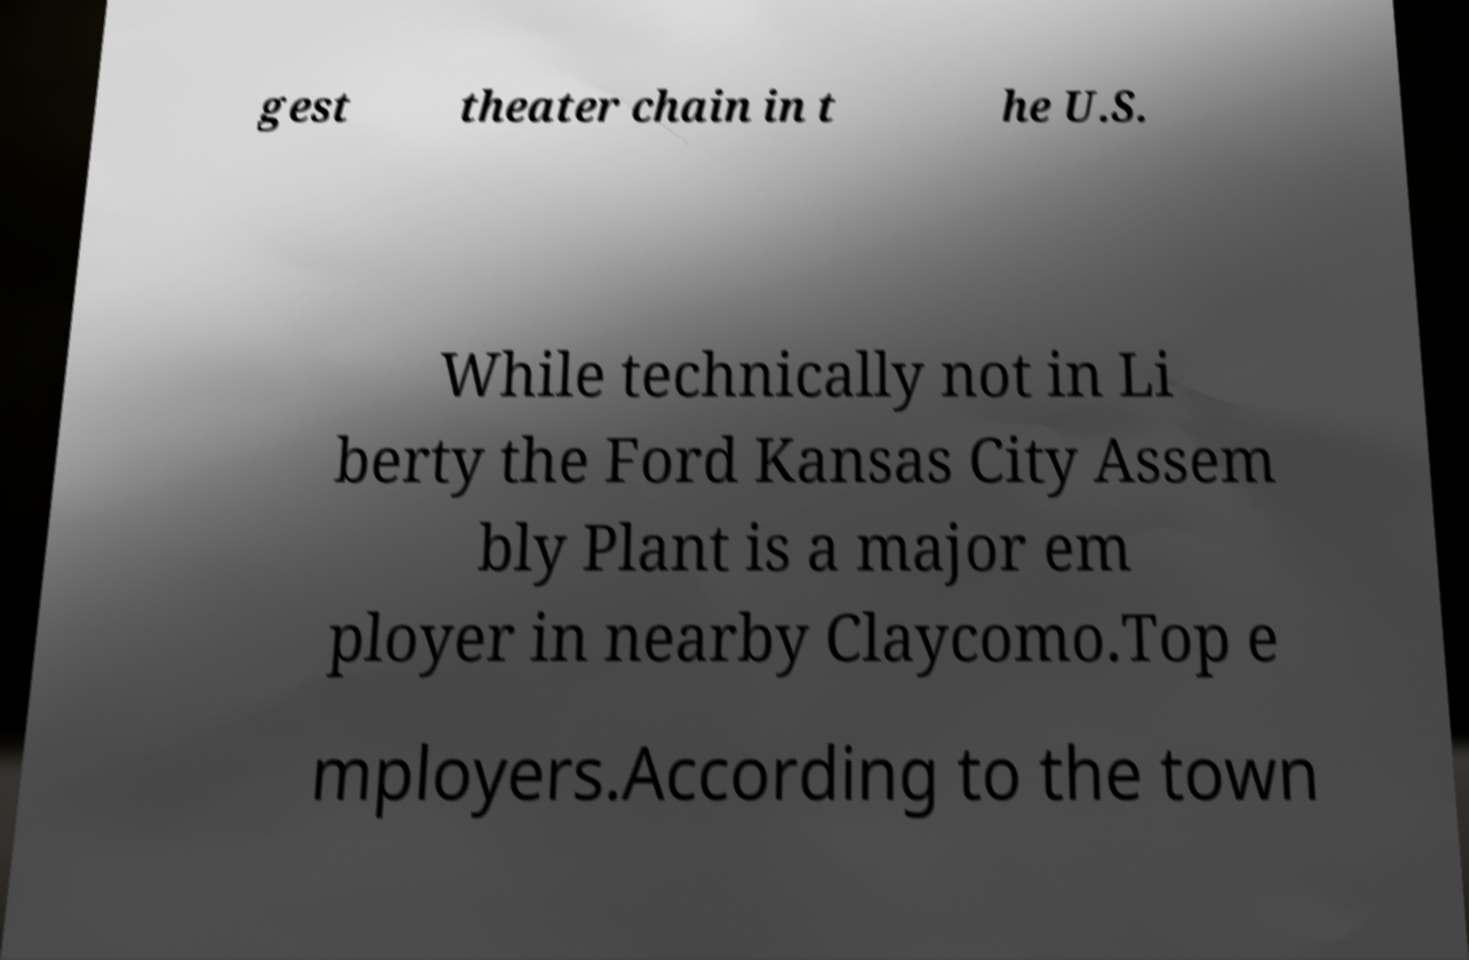I need the written content from this picture converted into text. Can you do that? gest theater chain in t he U.S. While technically not in Li berty the Ford Kansas City Assem bly Plant is a major em ployer in nearby Claycomo.Top e mployers.According to the town 